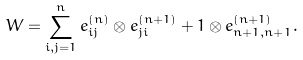<formula> <loc_0><loc_0><loc_500><loc_500>W = \sum _ { i , j = 1 } ^ { n } e _ { i j } ^ { ( n ) } \otimes e _ { j i } ^ { ( n + 1 ) } + 1 \otimes e _ { n + 1 , n + 1 } ^ { ( n + 1 ) } .</formula> 